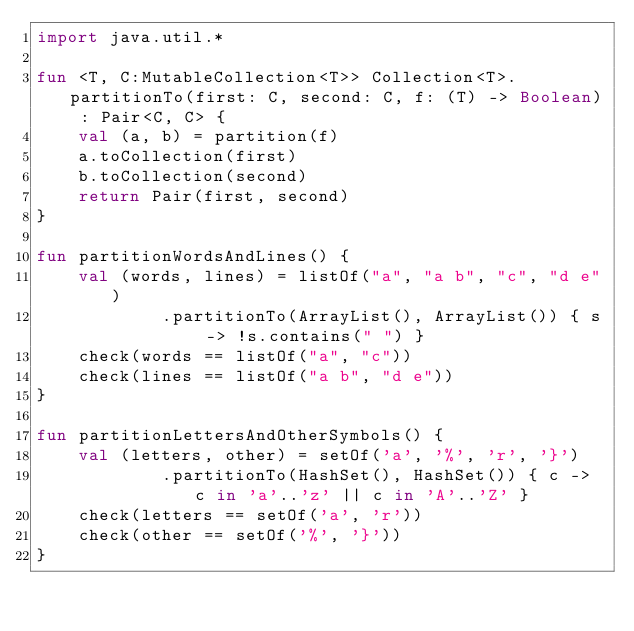<code> <loc_0><loc_0><loc_500><loc_500><_Kotlin_>import java.util.*

fun <T, C:MutableCollection<T>> Collection<T>.partitionTo(first: C, second: C, f: (T) -> Boolean) : Pair<C, C> {
    val (a, b) = partition(f)
    a.toCollection(first)
    b.toCollection(second)
    return Pair(first, second)
}

fun partitionWordsAndLines() {
    val (words, lines) = listOf("a", "a b", "c", "d e")
            .partitionTo(ArrayList(), ArrayList()) { s -> !s.contains(" ") }
    check(words == listOf("a", "c"))
    check(lines == listOf("a b", "d e"))
}

fun partitionLettersAndOtherSymbols() {
    val (letters, other) = setOf('a', '%', 'r', '}')
            .partitionTo(HashSet(), HashSet()) { c -> c in 'a'..'z' || c in 'A'..'Z' }
    check(letters == setOf('a', 'r'))
    check(other == setOf('%', '}'))
}
</code> 